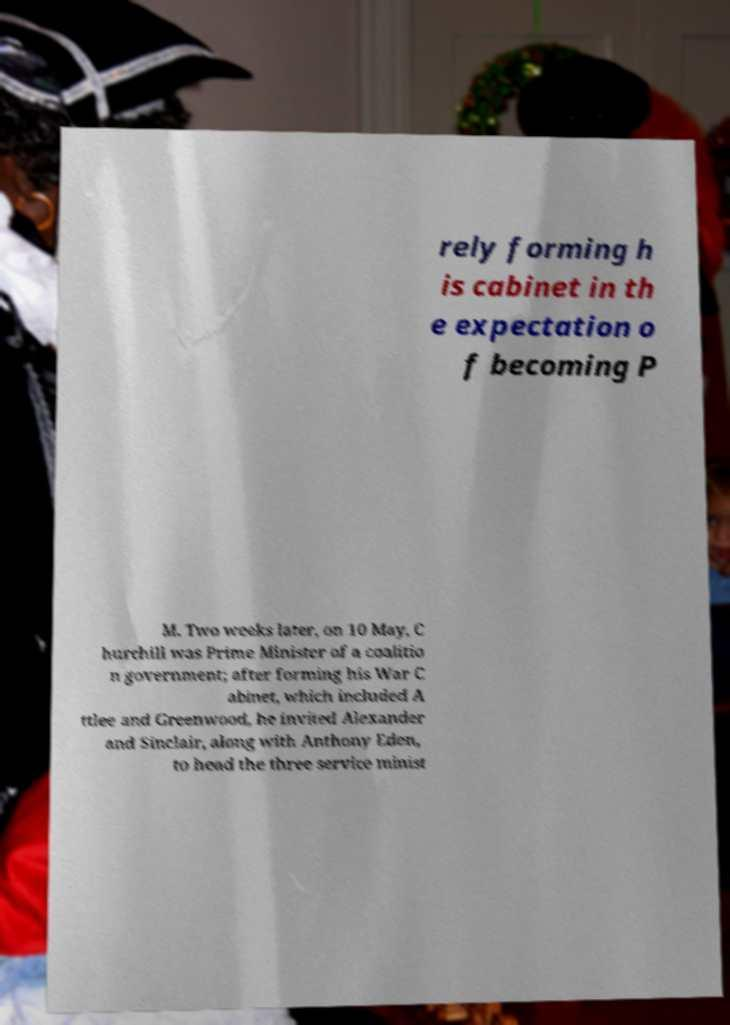What messages or text are displayed in this image? I need them in a readable, typed format. rely forming h is cabinet in th e expectation o f becoming P M. Two weeks later, on 10 May, C hurchill was Prime Minister of a coalitio n government; after forming his War C abinet, which included A ttlee and Greenwood, he invited Alexander and Sinclair, along with Anthony Eden, to head the three service minist 